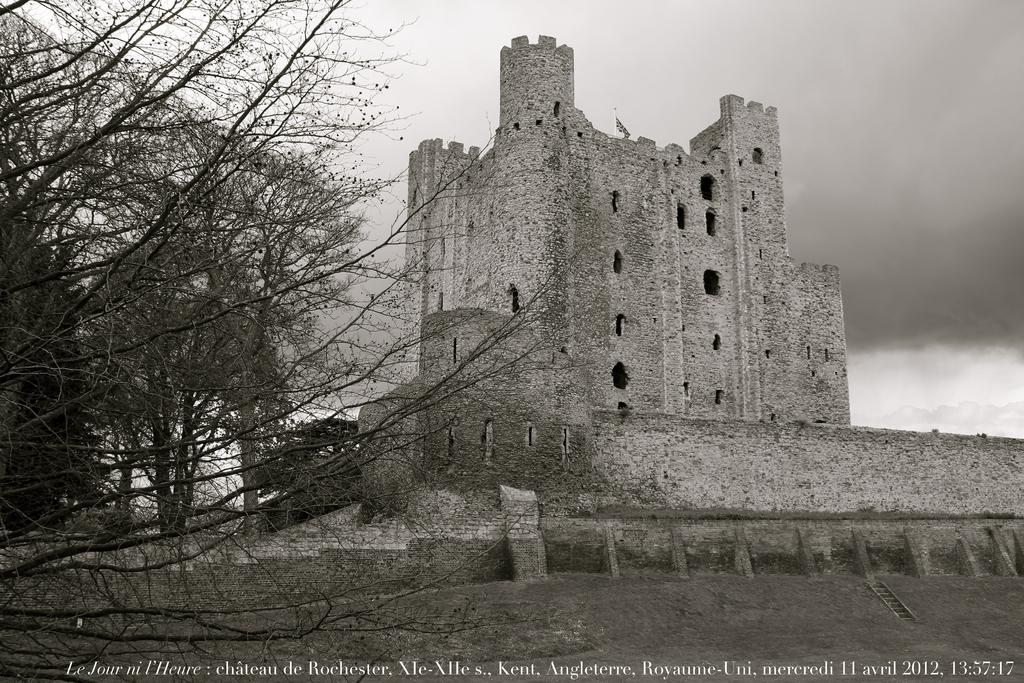What is the color scheme of the image? The image is black and white. What is the main structure visible in the image? There is a fort in the image. What type of vegetation can be seen in the foreground of the image? There is a dry tree in the foreground of the image. Is there any text present in the image? Yes, there is some text at the bottom of the image. What type of balance is being demonstrated on the stage in the image? There is no stage or balance act present in the image; it features a fort and a dry tree. 